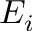<formula> <loc_0><loc_0><loc_500><loc_500>E _ { i }</formula> 